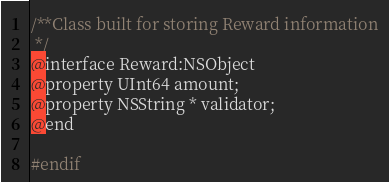<code> <loc_0><loc_0><loc_500><loc_500><_C_>/**Class built for storing Reward information
 */
@interface Reward:NSObject
@property UInt64 amount;
@property NSString * validator;
@end

#endif 
</code> 